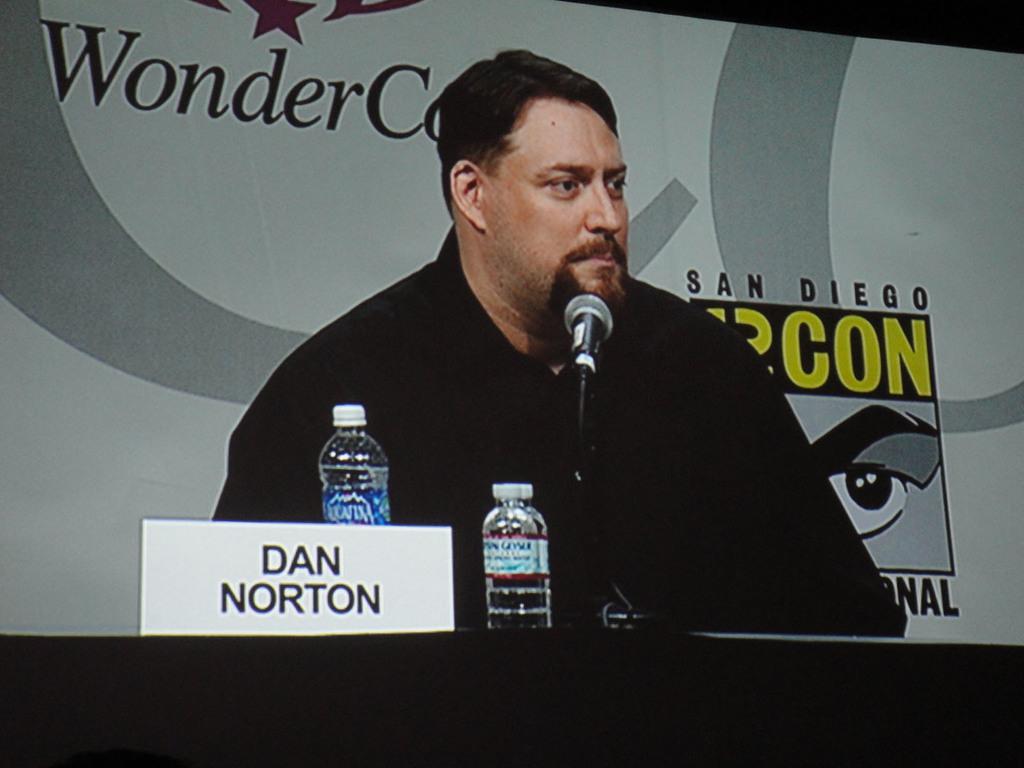How would you summarize this image in a sentence or two? The picture consists of a television screen, in the television screen there is a person sitting wearing a black dress. At the bottom there is a table, on the table there are bottles, mic and name plate. In the background is a banner. 